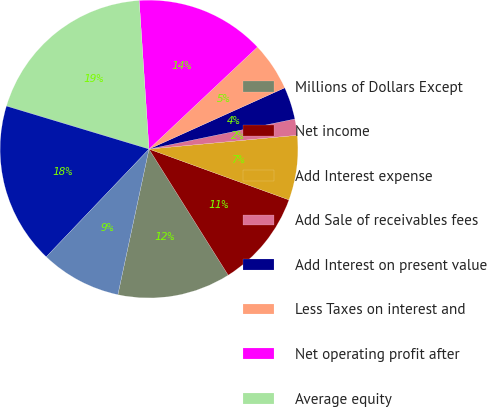Convert chart to OTSL. <chart><loc_0><loc_0><loc_500><loc_500><pie_chart><fcel>Millions of Dollars Except<fcel>Net income<fcel>Add Interest expense<fcel>Add Sale of receivables fees<fcel>Add Interest on present value<fcel>Less Taxes on interest and<fcel>Net operating profit after<fcel>Average equity<fcel>Add Average debt<fcel>Add Average value of sold<nl><fcel>12.28%<fcel>10.53%<fcel>7.02%<fcel>1.76%<fcel>3.51%<fcel>5.27%<fcel>14.03%<fcel>19.29%<fcel>17.54%<fcel>8.77%<nl></chart> 